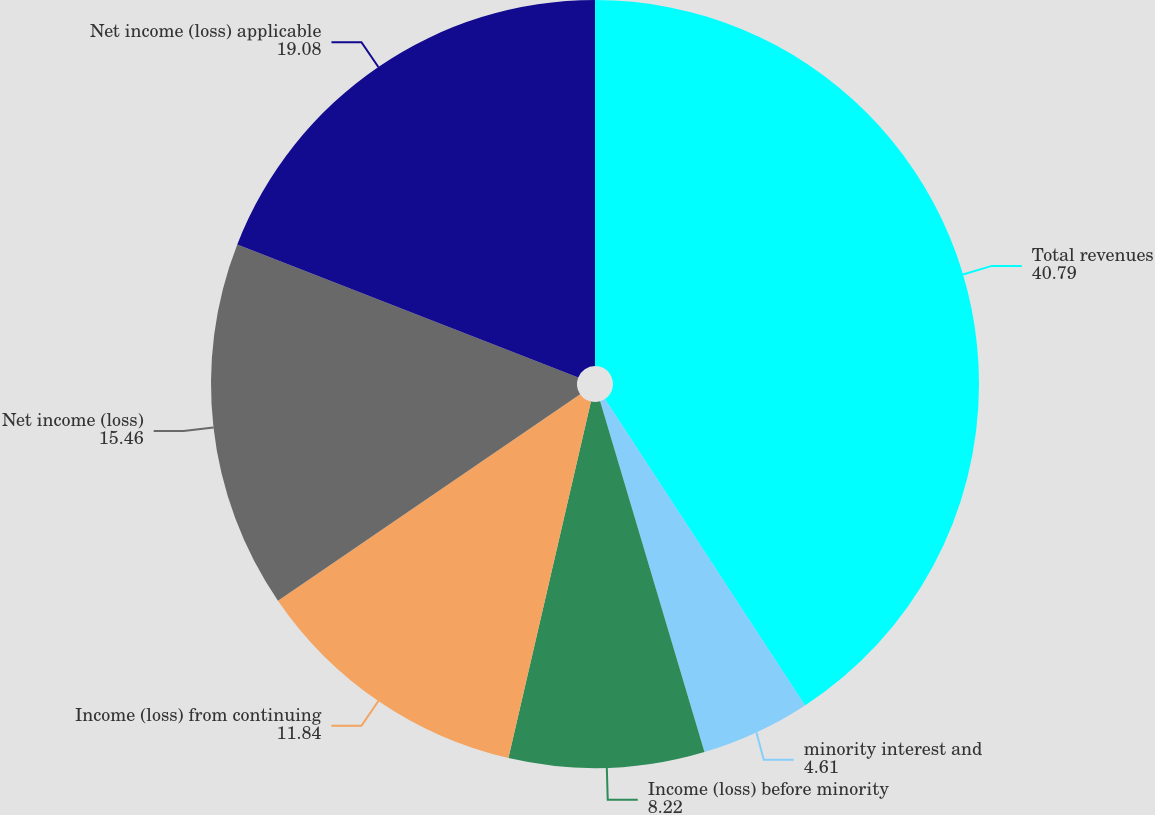<chart> <loc_0><loc_0><loc_500><loc_500><pie_chart><fcel>Total revenues<fcel>minority interest and<fcel>Income (loss) before minority<fcel>Income (loss) from continuing<fcel>Net income (loss)<fcel>Net income (loss) applicable<nl><fcel>40.79%<fcel>4.61%<fcel>8.22%<fcel>11.84%<fcel>15.46%<fcel>19.08%<nl></chart> 